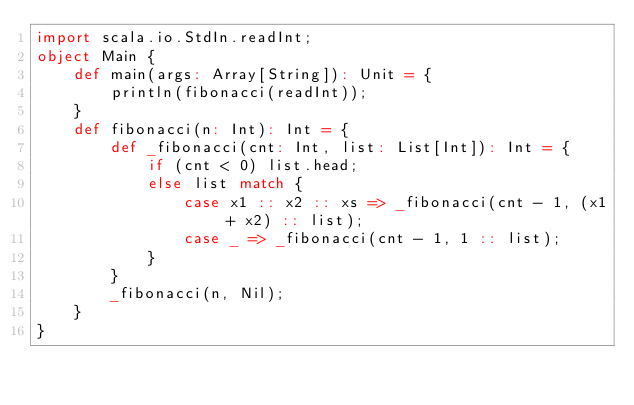Convert code to text. <code><loc_0><loc_0><loc_500><loc_500><_Scala_>import scala.io.StdIn.readInt;
object Main {
    def main(args: Array[String]): Unit = {
        println(fibonacci(readInt));
    }
    def fibonacci(n: Int): Int = {
        def _fibonacci(cnt: Int, list: List[Int]): Int = {
            if (cnt < 0) list.head;
            else list match {
                case x1 :: x2 :: xs => _fibonacci(cnt - 1, (x1 + x2) :: list);
                case _ => _fibonacci(cnt - 1, 1 :: list);
            }
        }
        _fibonacci(n, Nil);
    }
}
</code> 